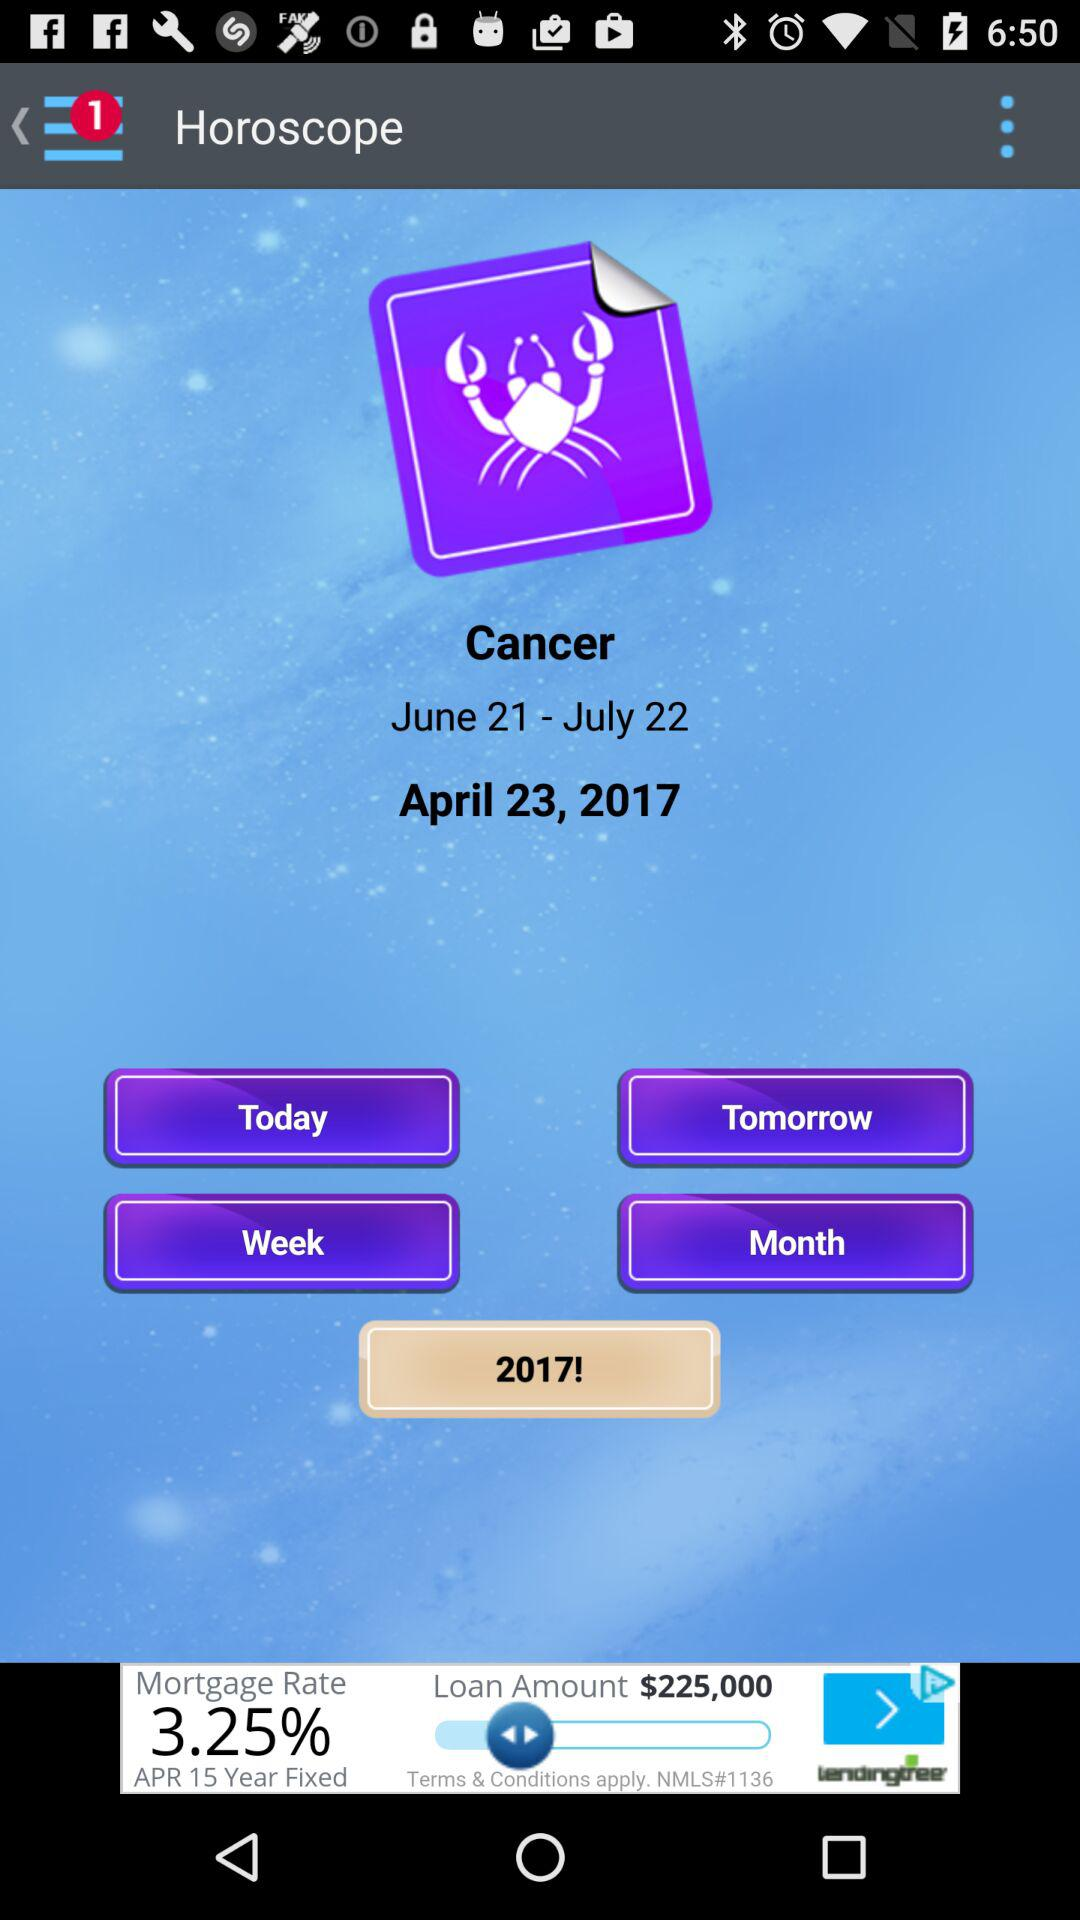Are there any unread notifications? There is 1 unread notification. 